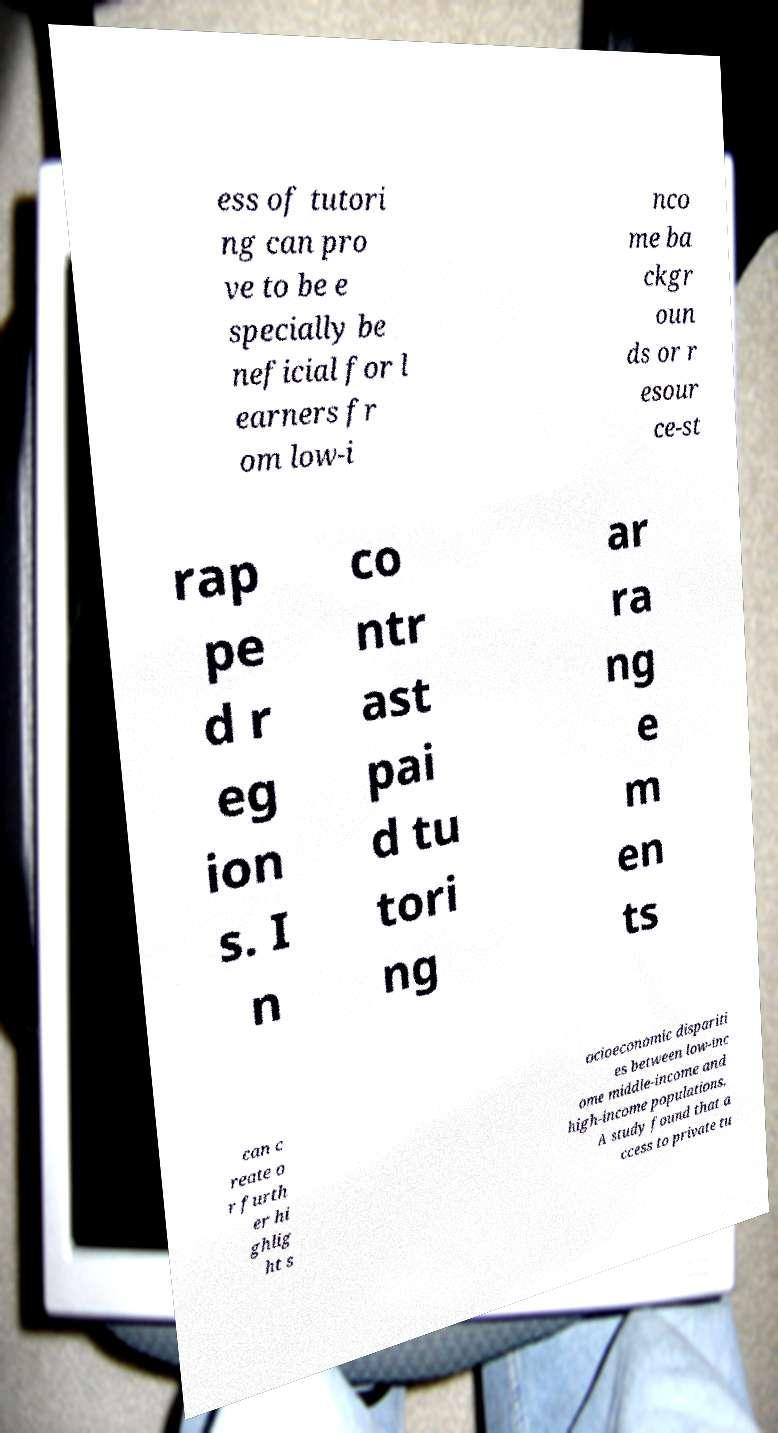Could you extract and type out the text from this image? ess of tutori ng can pro ve to be e specially be neficial for l earners fr om low-i nco me ba ckgr oun ds or r esour ce-st rap pe d r eg ion s. I n co ntr ast pai d tu tori ng ar ra ng e m en ts can c reate o r furth er hi ghlig ht s ocioeconomic dispariti es between low-inc ome middle-income and high-income populations. A study found that a ccess to private tu 